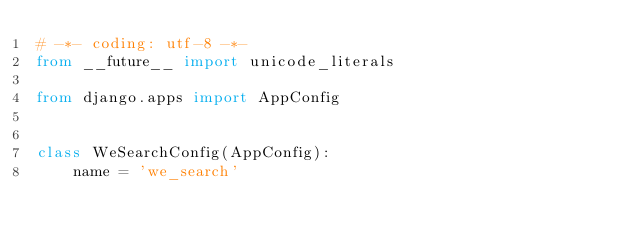Convert code to text. <code><loc_0><loc_0><loc_500><loc_500><_Python_># -*- coding: utf-8 -*-
from __future__ import unicode_literals

from django.apps import AppConfig


class WeSearchConfig(AppConfig):
    name = 'we_search'
</code> 